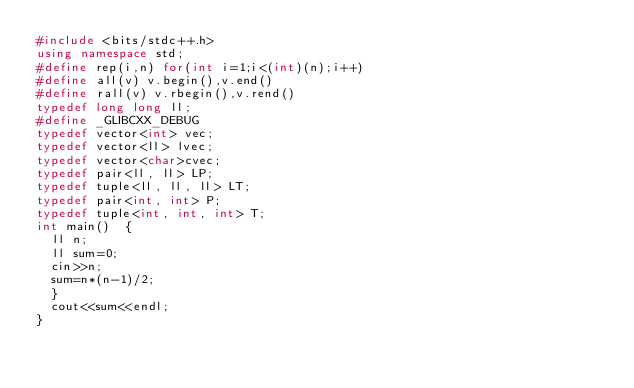Convert code to text. <code><loc_0><loc_0><loc_500><loc_500><_C++_>#include <bits/stdc++.h>
using namespace std;
#define rep(i,n) for(int i=1;i<(int)(n);i++)
#define all(v) v.begin(),v.end()
#define rall(v) v.rbegin(),v.rend()
typedef long long ll;
#define _GLIBCXX_DEBUG
typedef vector<int> vec;
typedef vector<ll> lvec;
typedef vector<char>cvec;
typedef pair<ll, ll> LP;
typedef tuple<ll, ll, ll> LT;
typedef pair<int, int> P;
typedef tuple<int, int, int> T;
int main()	{
  ll n;
  ll sum=0;
  cin>>n;
  sum=n*(n-1)/2;
  }
  cout<<sum<<endl;
}</code> 